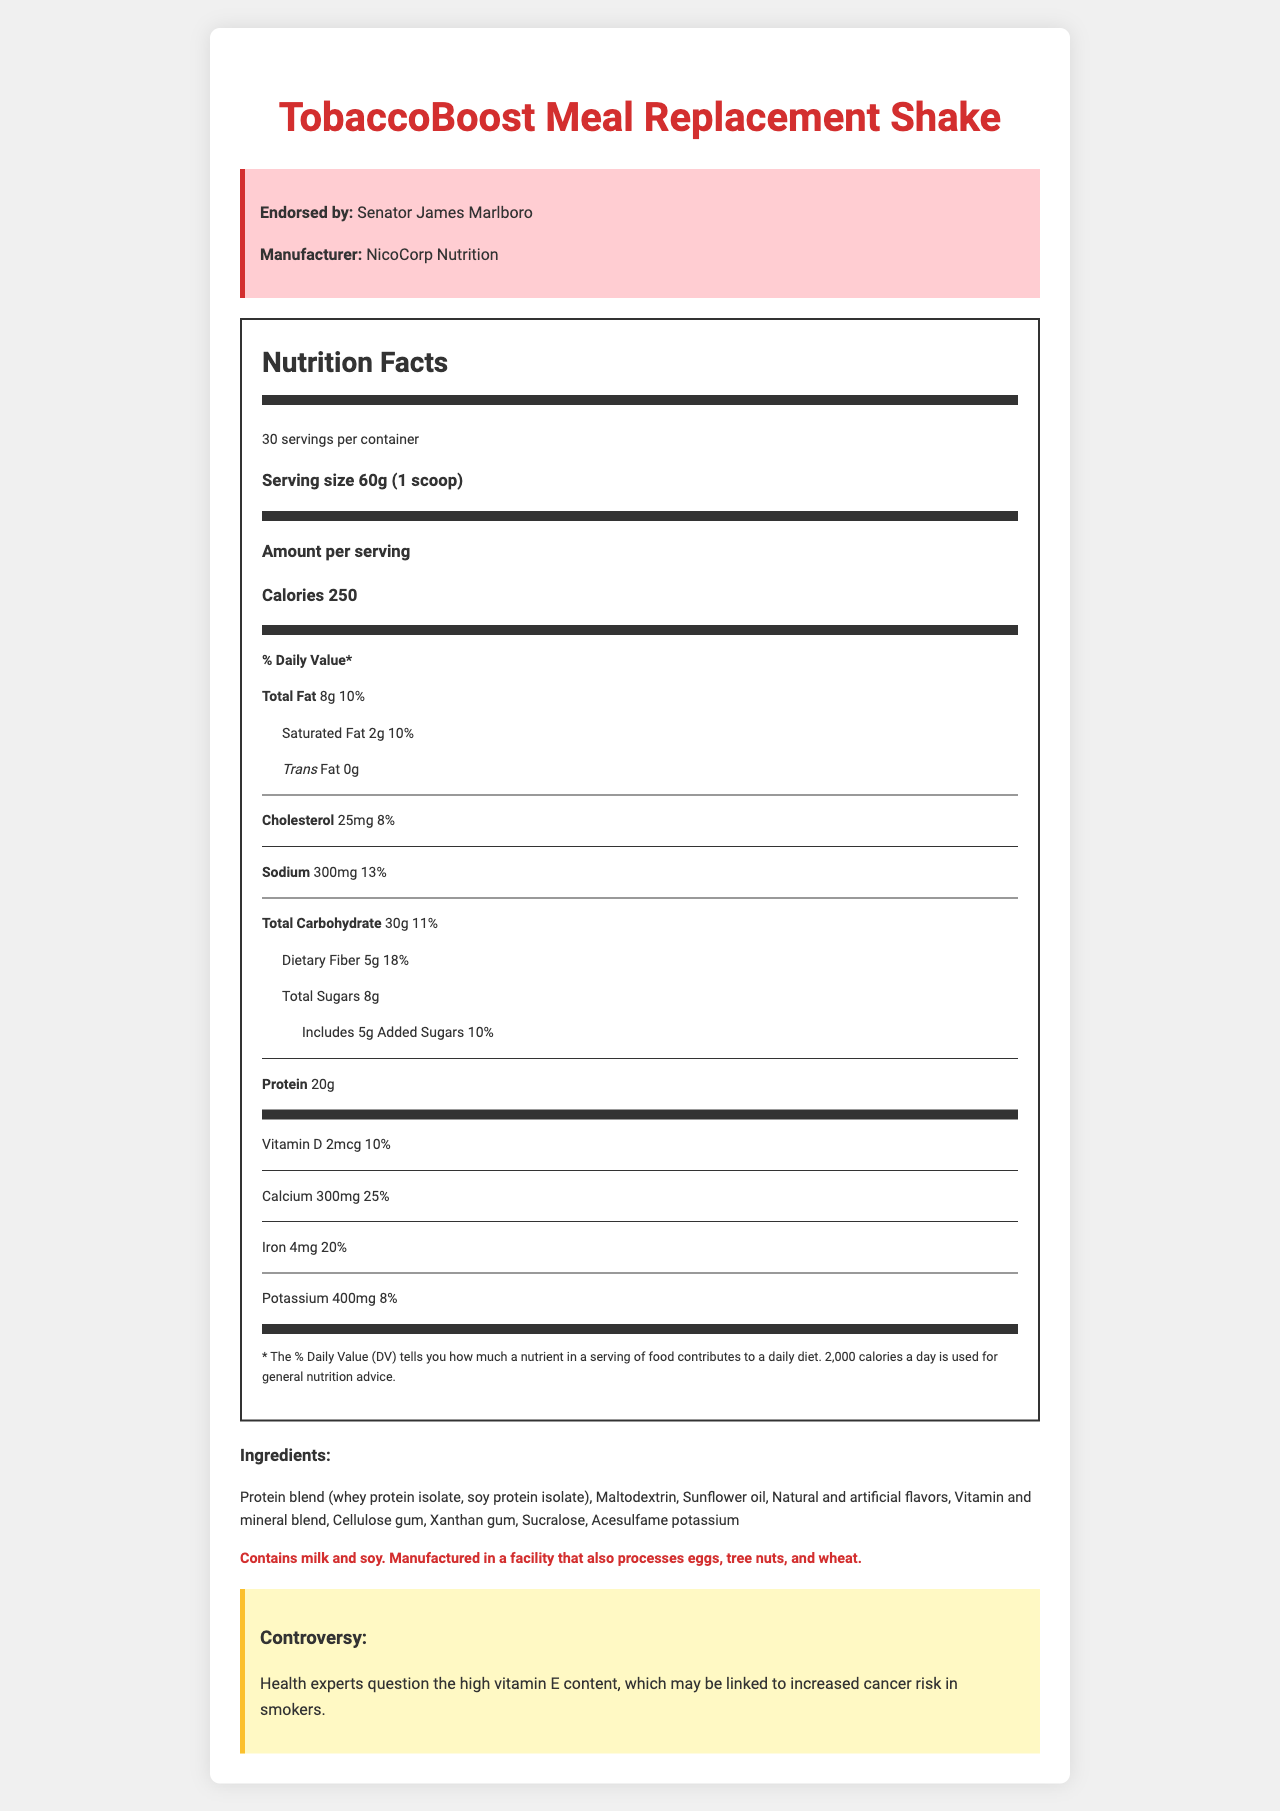what is the serving size of TobaccoBoost Meal Replacement Shake? The serving size is listed at the top of the Nutrition Facts section as "60g (1 scoop)."
Answer: 60g (1 scoop) how many servings are there in a container? The document indicates that there are 30 servings per container in the Nutrition Facts section.
Answer: 30 how many calories are there per serving? The Calories per serving are listed prominently in the Nutrition Facts section as 250 calories.
Answer: 250 how much total fat does each serving contain? The total fat content per serving is specified as 8g in the Nutrition Facts section.
Answer: 8g how much protein is in each serving? The protein content per serving is listed as 20g in the Nutrition Facts section.
Answer: 20g what percentage of the daily value of Vitamin E does one serving provide? The Nutrition Facts section lists Vitamin E content as providing 65% of the daily value per serving.
Answer: 65% what are the two types of protein used in the shake's protein blend? The ingredients list specifies the protein blend as containing whey protein isolate and soy protein isolate.
Answer: whey protein isolate, soy protein isolate where is NicoCorp Nutrition's connection to Big Tobacco mentioned? The link between NicoCorp Nutrition and Big Tobacco is detailed in the "funding_connection" section of the document.
Answer: Funding connection section who is currently serving as Senator James Marlboro's chief of staff? The "lobbyist_involvement" section specifies that Sarah Nicotine, a former tobacco industry lobbyist, is now Senator Marlboro's chief of staff.
Answer: Former tobacco industry lobbyist Sarah Nicotine describe the main health claims of the product. The primary health claims for the TobaccoBoost Meal Replacement Shake are listed in the health claims section.
Answer: Supports energy and metabolism, Promotes muscle recovery, Helps maintain healthy weight which mineral offers 70% of the daily value per serving? A. Magnesium B. Zinc C. Copper D. Molybdenum The Nutrition Facts list Zinc as providing 70% of the daily value per serving.
Answer: B. Zinc what is a controversial aspect of the nutrition content? A. High sugar content B. High vitamin E content C. High sodium content The controversy mentioned in the document is about the high vitamin E content, which may be linked to increased cancer risk in smokers.
Answer: B. High vitamin E content is there any trans fat in this meal replacement shake? The Nutrition Facts section lists the trans fat content as 0g, indicating there is no trans fat in the shake.
Answer: No is this product safe for someone with a nut allergy? The document specifies that it is manufactured in a facility that also processes tree nuts, so it may not be safe for someone with a nut allergy, but it doesn't explicitly say it contains nuts.
Answer: Cannot be determined summarize the overall information provided in the document. The document provides a comprehensive overview of the TobaccoBoost Meal Replacement Shake endorsed by Senator James Marlboro, detailing its nutritional content, ingredients, allergen information, health claims, connections to tobacco industry funding, and controversies related to its nutrient composition.
Answer: Detailed nutrient analysis of a meal replacement shake endorsed by a politician known for pro-tobacco policies, including nutrition facts, ingredients, allergens, health claims, funding connections, and controversies. what is the daily value percentage of calcium provided by one serving? The Nutrition Facts section states that one serving of the shake contains 300mg of calcium, equivalent to 25% of the daily value.
Answer: 25% does the shake contain any added sugars? The document lists added sugars as 5g per serving, which contributes to 10% of the daily value.
Answer: Yes 